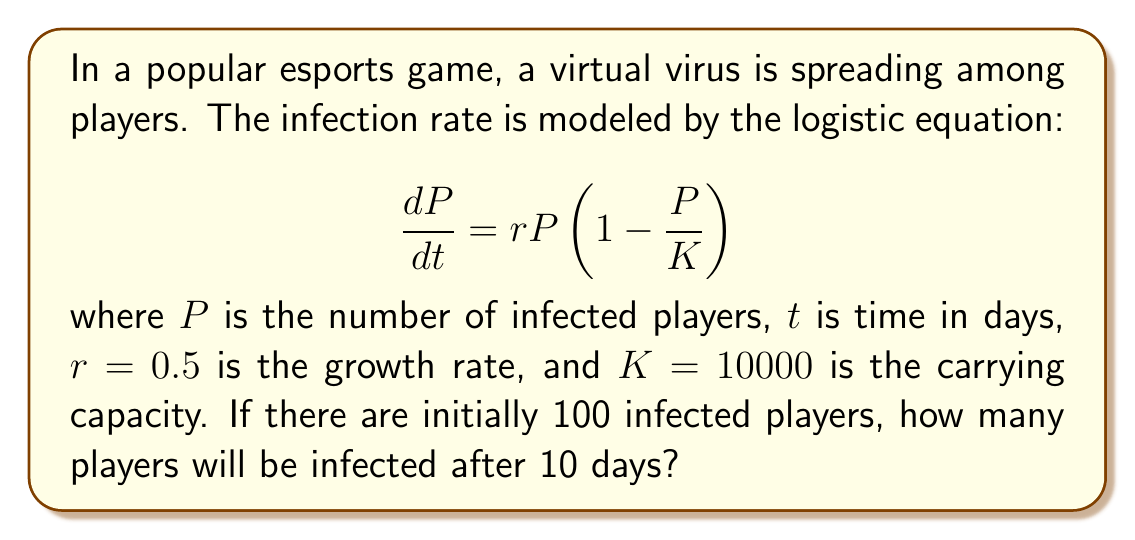Can you solve this math problem? To solve this problem, we need to use the solution to the logistic equation:

1. The solution to the logistic equation is given by:

   $$P(t) = \frac{K}{1 + (\frac{K}{P_0} - 1)e^{-rt}}$$

   where $P_0$ is the initial number of infected players.

2. We are given:
   - $K = 10000$ (carrying capacity)
   - $r = 0.5$ (growth rate)
   - $P_0 = 100$ (initial infected players)
   - $t = 10$ (days)

3. Let's substitute these values into the equation:

   $$P(10) = \frac{10000}{1 + (\frac{10000}{100} - 1)e^{-0.5 \cdot 10}}$$

4. Simplify:
   $$P(10) = \frac{10000}{1 + 99e^{-5}}$$

5. Calculate $e^{-5} \approx 0.00674$:
   $$P(10) = \frac{10000}{1 + 99 \cdot 0.00674} \approx \frac{10000}{1.66726}$$

6. Evaluate:
   $$P(10) \approx 5997.47$$

7. Since we're dealing with whole players, we round to the nearest integer:
   $$P(10) \approx 5997$$
Answer: 5997 players 